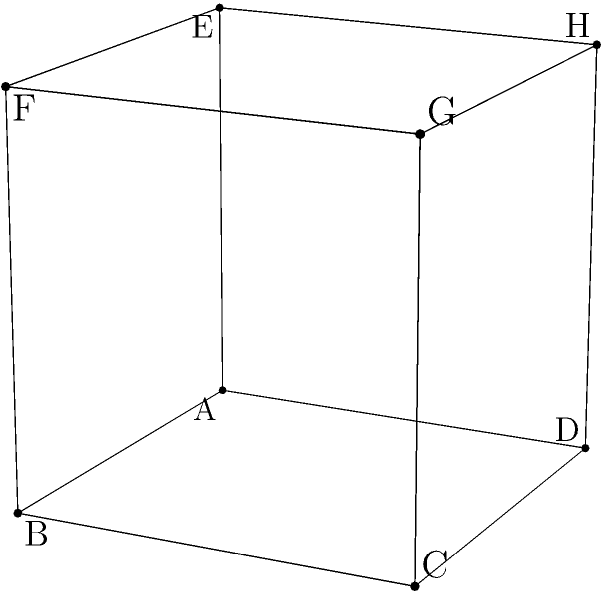Imagine you're explaining this to a fellow patient: If the cube shown above is rotated 90 degrees clockwise around the vertical axis (from face ABCD to BFGC), which face will be in front? Let's approach this step-by-step, as if we're walking through it together:

1. First, let's identify the current front face: It's the blue face ABCD.

2. Now, we're rotating 90 degrees clockwise around the vertical axis. This means:
   - The front face (ABCD) will move to the right
   - The right face will become the new front face

3. To find the right face in the initial position:
   - It shares two vertices with the front face (B and C)
   - The other two vertices are on the back of the cube (F and G)

4. So, the right face in the initial position is BFGC

5. After rotation, this face BFGC will become the new front face

6. To double-check:
   - B moves to where A was
   - F moves to where B was
   - G moves to where C was
   - C moves to where D was

Remember, visualizing these rotations can be challenging, especially when recovering from a brain lesion. It's okay to take your time and perhaps use a physical object to help you understand the movement better.
Answer: BFGC 